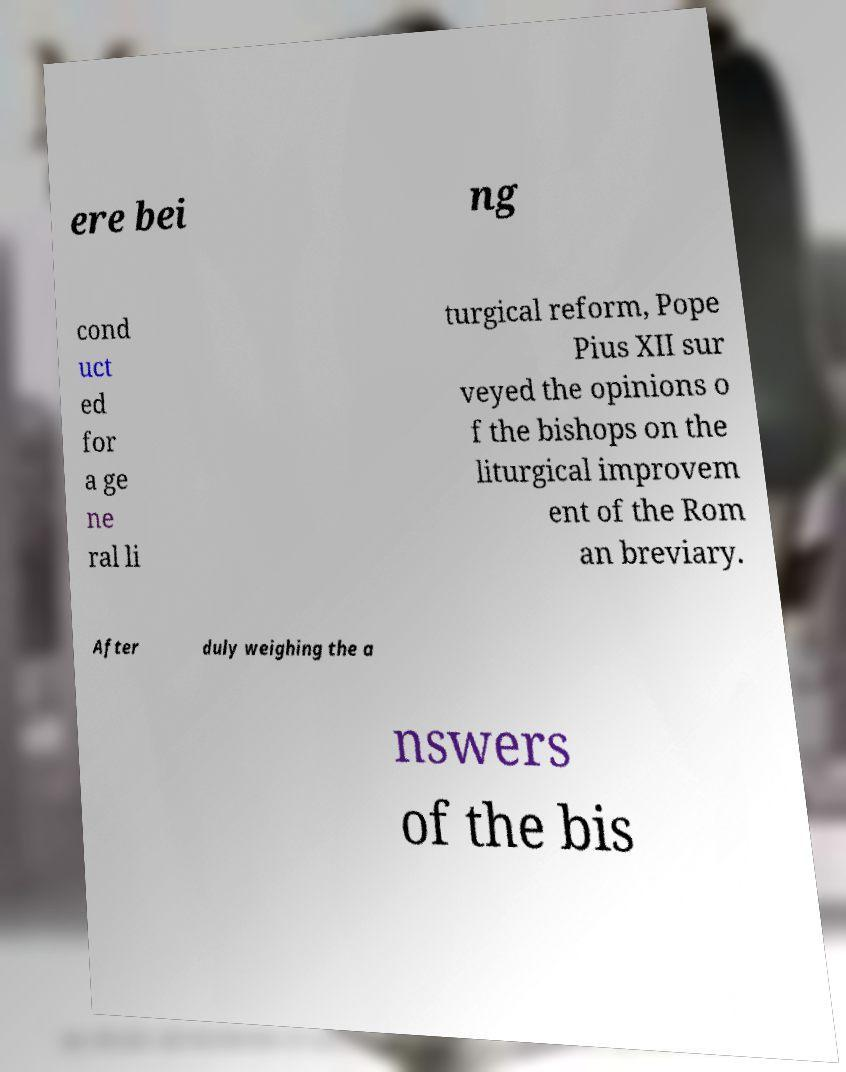Please read and relay the text visible in this image. What does it say? ere bei ng cond uct ed for a ge ne ral li turgical reform, Pope Pius XII sur veyed the opinions o f the bishops on the liturgical improvem ent of the Rom an breviary. After duly weighing the a nswers of the bis 